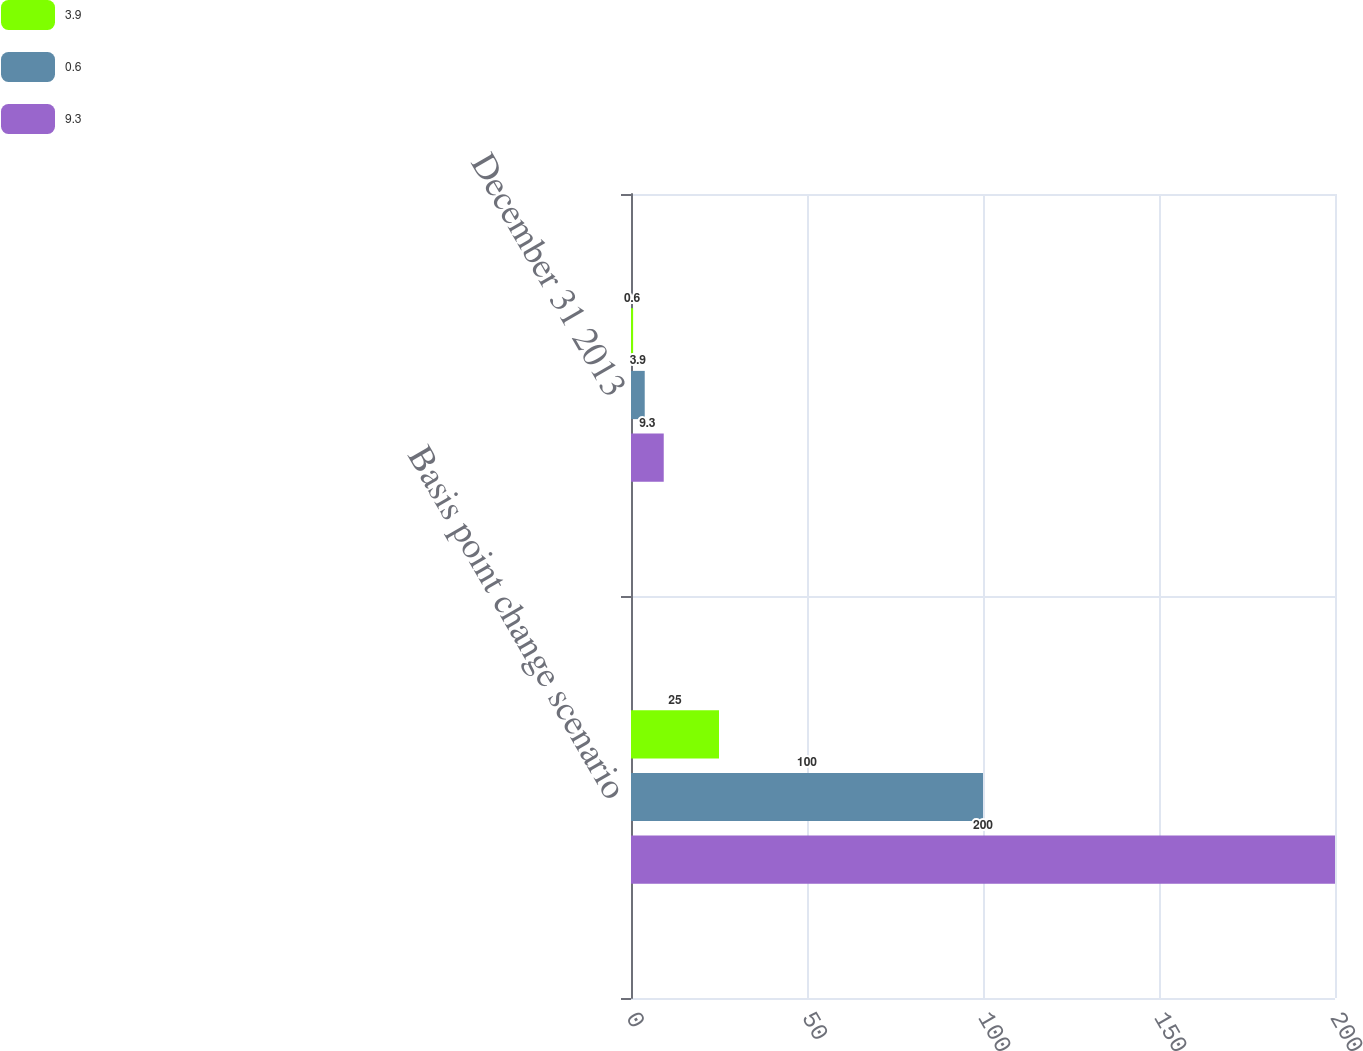Convert chart to OTSL. <chart><loc_0><loc_0><loc_500><loc_500><stacked_bar_chart><ecel><fcel>Basis point change scenario<fcel>December 31 2013<nl><fcel>3.9<fcel>25<fcel>0.6<nl><fcel>0.6<fcel>100<fcel>3.9<nl><fcel>9.3<fcel>200<fcel>9.3<nl></chart> 